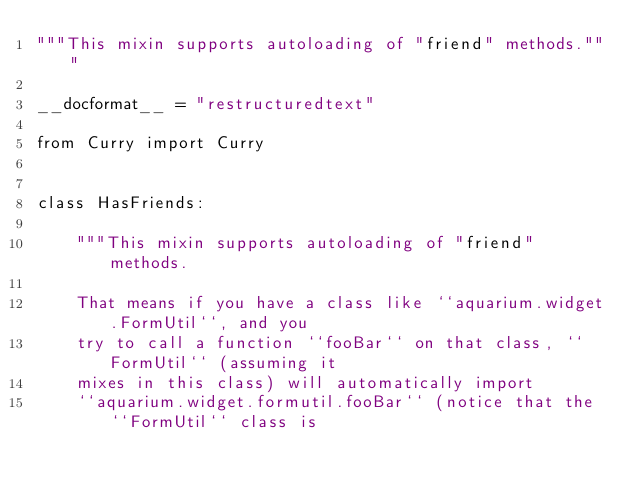<code> <loc_0><loc_0><loc_500><loc_500><_Python_>"""This mixin supports autoloading of "friend" methods."""

__docformat__ = "restructuredtext"

from Curry import Curry


class HasFriends:

    """This mixin supports autoloading of "friend" methods.

    That means if you have a class like ``aquarium.widget.FormUtil``, and you
    try to call a function ``fooBar`` on that class, ``FormUtil`` (assuming it
    mixes in this class) will automatically import
    ``aquarium.widget.formutil.fooBar`` (notice that the ``FormUtil`` class is</code> 